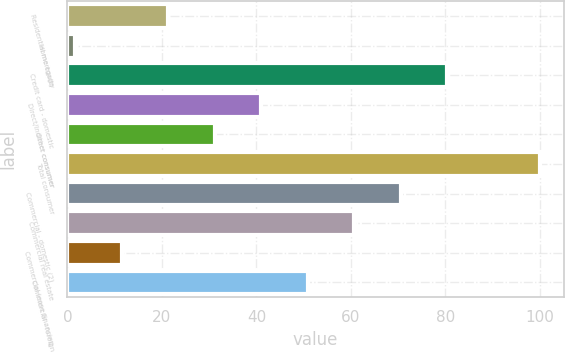<chart> <loc_0><loc_0><loc_500><loc_500><bar_chart><fcel>Residential mortgage<fcel>Home equity<fcel>Credit card - domestic<fcel>Direct/Indirect consumer<fcel>Other consumer<fcel>Total consumer<fcel>Commercial - domestic (2)<fcel>Commercial real estate<fcel>Commercial lease financing<fcel>Commercial - foreign<nl><fcel>21.35<fcel>1.69<fcel>80.33<fcel>41.01<fcel>31.18<fcel>99.99<fcel>70.5<fcel>60.67<fcel>11.52<fcel>50.84<nl></chart> 